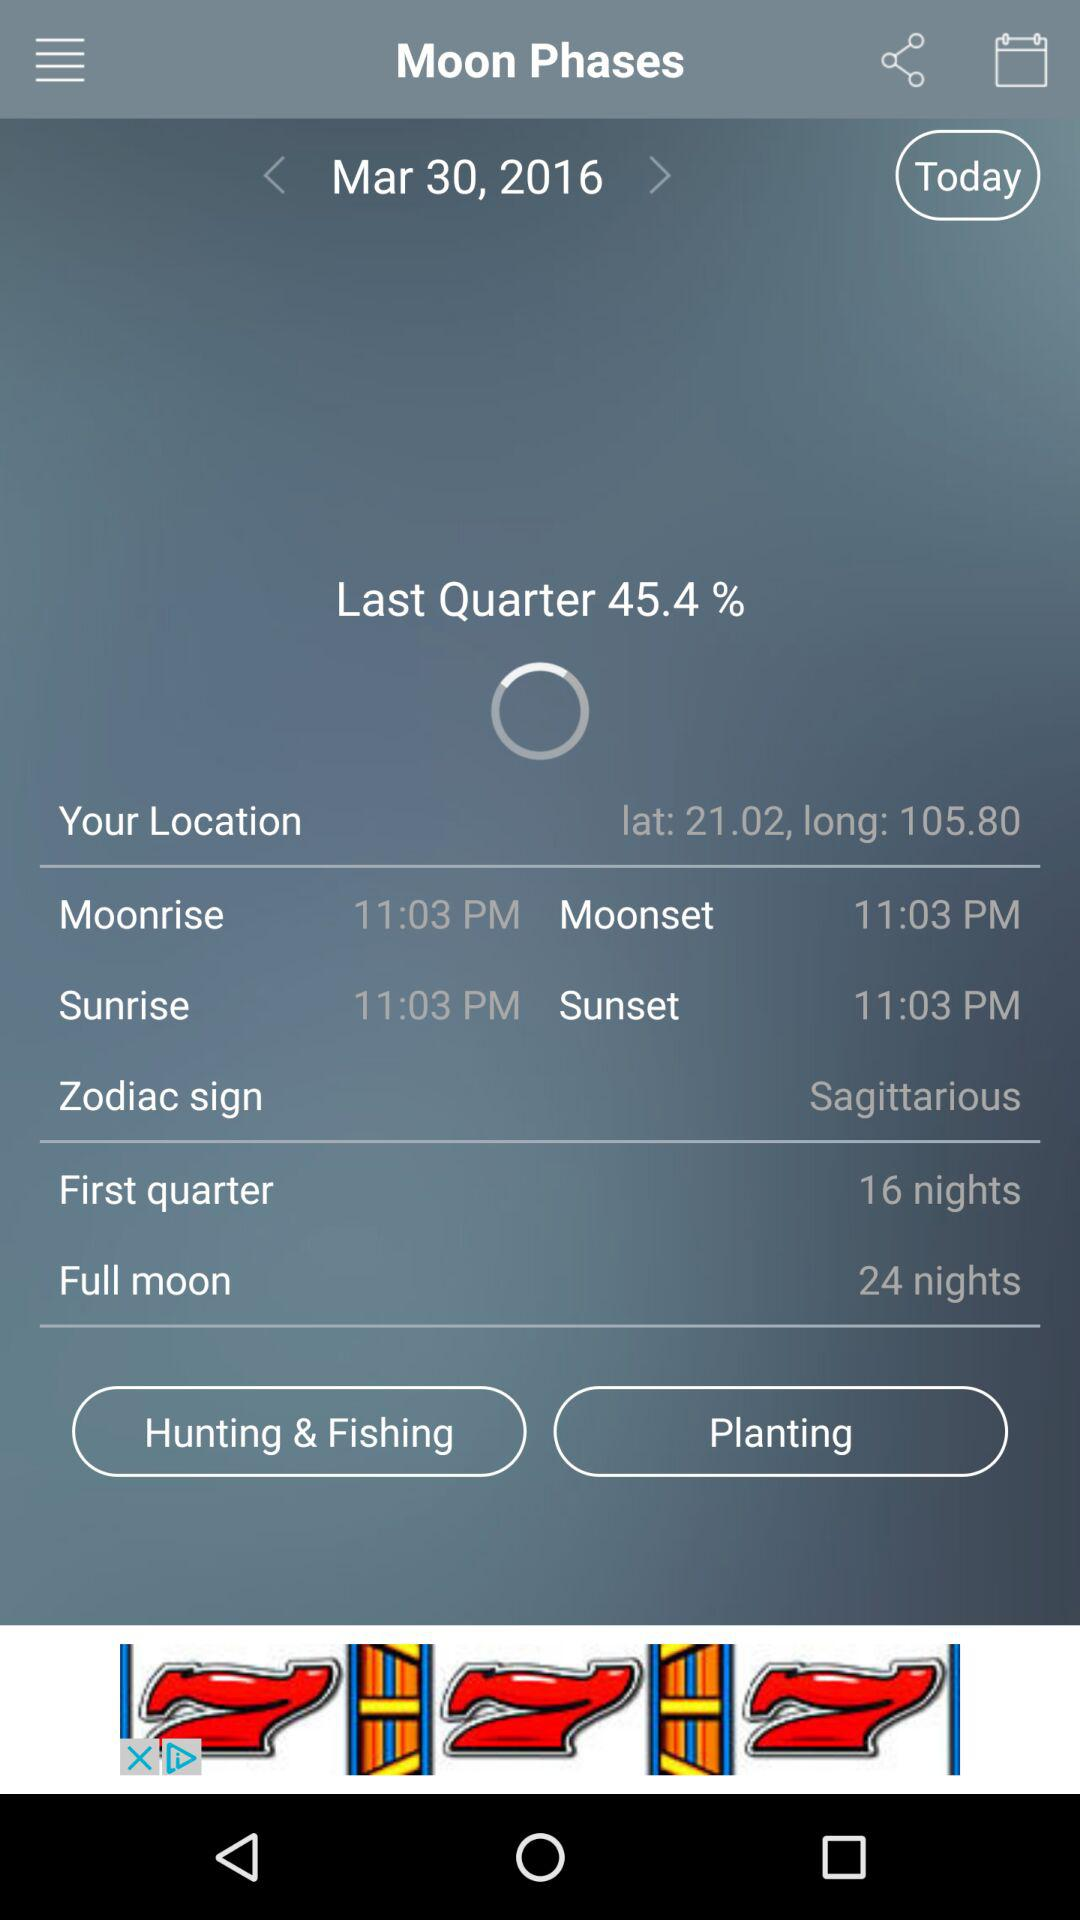What is the zodiac sign? The zodiac sign is Sagittarious. 